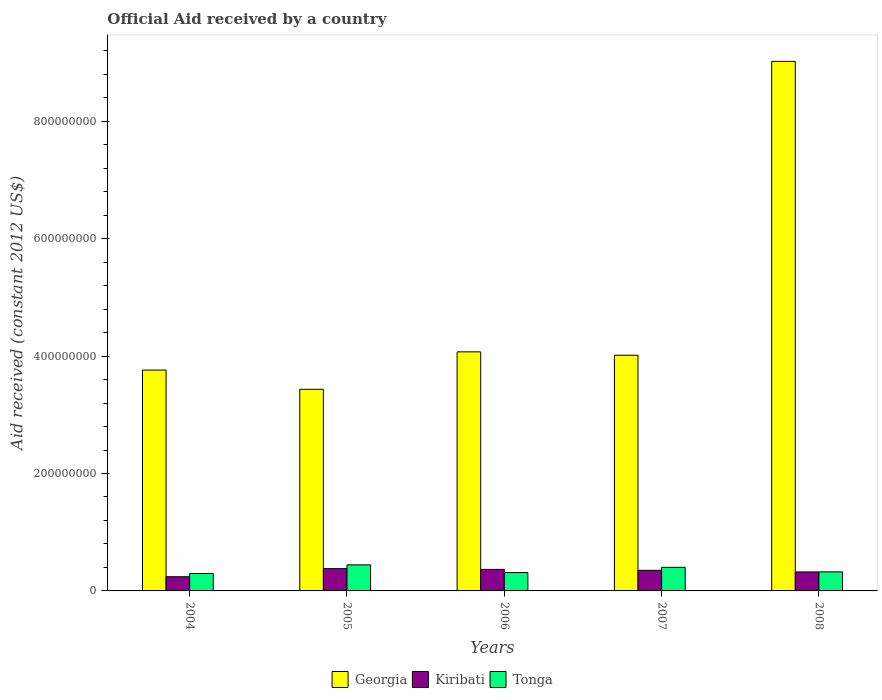How many different coloured bars are there?
Your answer should be very brief. 3. Are the number of bars per tick equal to the number of legend labels?
Provide a short and direct response. Yes. What is the label of the 5th group of bars from the left?
Provide a succinct answer. 2008. What is the net official aid received in Tonga in 2007?
Your response must be concise. 4.02e+07. Across all years, what is the maximum net official aid received in Kiribati?
Your answer should be very brief. 3.80e+07. Across all years, what is the minimum net official aid received in Kiribati?
Your response must be concise. 2.42e+07. In which year was the net official aid received in Georgia maximum?
Offer a very short reply. 2008. What is the total net official aid received in Tonga in the graph?
Your answer should be very brief. 1.78e+08. What is the difference between the net official aid received in Georgia in 2004 and that in 2007?
Your answer should be very brief. -2.53e+07. What is the difference between the net official aid received in Tonga in 2006 and the net official aid received in Georgia in 2004?
Provide a succinct answer. -3.45e+08. What is the average net official aid received in Georgia per year?
Your response must be concise. 4.86e+08. In the year 2006, what is the difference between the net official aid received in Georgia and net official aid received in Kiribati?
Your answer should be compact. 3.71e+08. In how many years, is the net official aid received in Georgia greater than 720000000 US$?
Keep it short and to the point. 1. What is the ratio of the net official aid received in Georgia in 2004 to that in 2007?
Make the answer very short. 0.94. What is the difference between the highest and the second highest net official aid received in Tonga?
Ensure brevity in your answer.  4.17e+06. What is the difference between the highest and the lowest net official aid received in Kiribati?
Your response must be concise. 1.38e+07. In how many years, is the net official aid received in Georgia greater than the average net official aid received in Georgia taken over all years?
Offer a very short reply. 1. Is the sum of the net official aid received in Kiribati in 2005 and 2008 greater than the maximum net official aid received in Tonga across all years?
Keep it short and to the point. Yes. What does the 3rd bar from the left in 2004 represents?
Make the answer very short. Tonga. What does the 1st bar from the right in 2008 represents?
Your answer should be very brief. Tonga. How many bars are there?
Your response must be concise. 15. Are all the bars in the graph horizontal?
Your answer should be very brief. No. How many years are there in the graph?
Make the answer very short. 5. What is the difference between two consecutive major ticks on the Y-axis?
Give a very brief answer. 2.00e+08. Are the values on the major ticks of Y-axis written in scientific E-notation?
Your answer should be very brief. No. Does the graph contain any zero values?
Make the answer very short. No. Does the graph contain grids?
Provide a succinct answer. No. Where does the legend appear in the graph?
Offer a terse response. Bottom center. How many legend labels are there?
Your response must be concise. 3. How are the legend labels stacked?
Provide a succinct answer. Horizontal. What is the title of the graph?
Make the answer very short. Official Aid received by a country. Does "Burkina Faso" appear as one of the legend labels in the graph?
Your answer should be compact. No. What is the label or title of the X-axis?
Ensure brevity in your answer.  Years. What is the label or title of the Y-axis?
Keep it short and to the point. Aid received (constant 2012 US$). What is the Aid received (constant 2012 US$) of Georgia in 2004?
Provide a succinct answer. 3.76e+08. What is the Aid received (constant 2012 US$) of Kiribati in 2004?
Provide a succinct answer. 2.42e+07. What is the Aid received (constant 2012 US$) of Tonga in 2004?
Your response must be concise. 2.96e+07. What is the Aid received (constant 2012 US$) of Georgia in 2005?
Give a very brief answer. 3.43e+08. What is the Aid received (constant 2012 US$) in Kiribati in 2005?
Your response must be concise. 3.80e+07. What is the Aid received (constant 2012 US$) in Tonga in 2005?
Offer a very short reply. 4.44e+07. What is the Aid received (constant 2012 US$) of Georgia in 2006?
Give a very brief answer. 4.07e+08. What is the Aid received (constant 2012 US$) in Kiribati in 2006?
Offer a very short reply. 3.67e+07. What is the Aid received (constant 2012 US$) in Tonga in 2006?
Ensure brevity in your answer.  3.12e+07. What is the Aid received (constant 2012 US$) in Georgia in 2007?
Your answer should be compact. 4.02e+08. What is the Aid received (constant 2012 US$) in Kiribati in 2007?
Make the answer very short. 3.51e+07. What is the Aid received (constant 2012 US$) in Tonga in 2007?
Your answer should be very brief. 4.02e+07. What is the Aid received (constant 2012 US$) of Georgia in 2008?
Give a very brief answer. 9.02e+08. What is the Aid received (constant 2012 US$) of Kiribati in 2008?
Your response must be concise. 3.23e+07. What is the Aid received (constant 2012 US$) of Tonga in 2008?
Your answer should be very brief. 3.24e+07. Across all years, what is the maximum Aid received (constant 2012 US$) of Georgia?
Your answer should be compact. 9.02e+08. Across all years, what is the maximum Aid received (constant 2012 US$) in Kiribati?
Your answer should be very brief. 3.80e+07. Across all years, what is the maximum Aid received (constant 2012 US$) in Tonga?
Your answer should be very brief. 4.44e+07. Across all years, what is the minimum Aid received (constant 2012 US$) in Georgia?
Keep it short and to the point. 3.43e+08. Across all years, what is the minimum Aid received (constant 2012 US$) in Kiribati?
Your response must be concise. 2.42e+07. Across all years, what is the minimum Aid received (constant 2012 US$) in Tonga?
Offer a very short reply. 2.96e+07. What is the total Aid received (constant 2012 US$) in Georgia in the graph?
Offer a terse response. 2.43e+09. What is the total Aid received (constant 2012 US$) in Kiribati in the graph?
Offer a terse response. 1.66e+08. What is the total Aid received (constant 2012 US$) of Tonga in the graph?
Offer a very short reply. 1.78e+08. What is the difference between the Aid received (constant 2012 US$) of Georgia in 2004 and that in 2005?
Provide a short and direct response. 3.28e+07. What is the difference between the Aid received (constant 2012 US$) of Kiribati in 2004 and that in 2005?
Offer a terse response. -1.38e+07. What is the difference between the Aid received (constant 2012 US$) of Tonga in 2004 and that in 2005?
Give a very brief answer. -1.47e+07. What is the difference between the Aid received (constant 2012 US$) in Georgia in 2004 and that in 2006?
Ensure brevity in your answer.  -3.10e+07. What is the difference between the Aid received (constant 2012 US$) in Kiribati in 2004 and that in 2006?
Make the answer very short. -1.25e+07. What is the difference between the Aid received (constant 2012 US$) in Tonga in 2004 and that in 2006?
Offer a terse response. -1.61e+06. What is the difference between the Aid received (constant 2012 US$) of Georgia in 2004 and that in 2007?
Give a very brief answer. -2.53e+07. What is the difference between the Aid received (constant 2012 US$) in Kiribati in 2004 and that in 2007?
Keep it short and to the point. -1.09e+07. What is the difference between the Aid received (constant 2012 US$) in Tonga in 2004 and that in 2007?
Your answer should be very brief. -1.06e+07. What is the difference between the Aid received (constant 2012 US$) of Georgia in 2004 and that in 2008?
Your response must be concise. -5.26e+08. What is the difference between the Aid received (constant 2012 US$) of Kiribati in 2004 and that in 2008?
Offer a terse response. -8.15e+06. What is the difference between the Aid received (constant 2012 US$) in Tonga in 2004 and that in 2008?
Provide a succinct answer. -2.80e+06. What is the difference between the Aid received (constant 2012 US$) of Georgia in 2005 and that in 2006?
Offer a very short reply. -6.38e+07. What is the difference between the Aid received (constant 2012 US$) in Kiribati in 2005 and that in 2006?
Provide a succinct answer. 1.26e+06. What is the difference between the Aid received (constant 2012 US$) in Tonga in 2005 and that in 2006?
Make the answer very short. 1.31e+07. What is the difference between the Aid received (constant 2012 US$) in Georgia in 2005 and that in 2007?
Give a very brief answer. -5.81e+07. What is the difference between the Aid received (constant 2012 US$) in Kiribati in 2005 and that in 2007?
Your answer should be very brief. 2.86e+06. What is the difference between the Aid received (constant 2012 US$) of Tonga in 2005 and that in 2007?
Keep it short and to the point. 4.17e+06. What is the difference between the Aid received (constant 2012 US$) of Georgia in 2005 and that in 2008?
Keep it short and to the point. -5.59e+08. What is the difference between the Aid received (constant 2012 US$) of Kiribati in 2005 and that in 2008?
Your answer should be very brief. 5.62e+06. What is the difference between the Aid received (constant 2012 US$) in Tonga in 2005 and that in 2008?
Your answer should be compact. 1.19e+07. What is the difference between the Aid received (constant 2012 US$) of Georgia in 2006 and that in 2007?
Provide a succinct answer. 5.75e+06. What is the difference between the Aid received (constant 2012 US$) in Kiribati in 2006 and that in 2007?
Your answer should be very brief. 1.60e+06. What is the difference between the Aid received (constant 2012 US$) of Tonga in 2006 and that in 2007?
Your answer should be compact. -8.95e+06. What is the difference between the Aid received (constant 2012 US$) of Georgia in 2006 and that in 2008?
Your answer should be compact. -4.95e+08. What is the difference between the Aid received (constant 2012 US$) of Kiribati in 2006 and that in 2008?
Make the answer very short. 4.36e+06. What is the difference between the Aid received (constant 2012 US$) in Tonga in 2006 and that in 2008?
Your answer should be compact. -1.19e+06. What is the difference between the Aid received (constant 2012 US$) of Georgia in 2007 and that in 2008?
Your answer should be compact. -5.01e+08. What is the difference between the Aid received (constant 2012 US$) in Kiribati in 2007 and that in 2008?
Provide a succinct answer. 2.76e+06. What is the difference between the Aid received (constant 2012 US$) in Tonga in 2007 and that in 2008?
Make the answer very short. 7.76e+06. What is the difference between the Aid received (constant 2012 US$) in Georgia in 2004 and the Aid received (constant 2012 US$) in Kiribati in 2005?
Keep it short and to the point. 3.38e+08. What is the difference between the Aid received (constant 2012 US$) of Georgia in 2004 and the Aid received (constant 2012 US$) of Tonga in 2005?
Your answer should be compact. 3.32e+08. What is the difference between the Aid received (constant 2012 US$) in Kiribati in 2004 and the Aid received (constant 2012 US$) in Tonga in 2005?
Give a very brief answer. -2.02e+07. What is the difference between the Aid received (constant 2012 US$) in Georgia in 2004 and the Aid received (constant 2012 US$) in Kiribati in 2006?
Make the answer very short. 3.40e+08. What is the difference between the Aid received (constant 2012 US$) in Georgia in 2004 and the Aid received (constant 2012 US$) in Tonga in 2006?
Your answer should be compact. 3.45e+08. What is the difference between the Aid received (constant 2012 US$) in Kiribati in 2004 and the Aid received (constant 2012 US$) in Tonga in 2006?
Provide a short and direct response. -7.06e+06. What is the difference between the Aid received (constant 2012 US$) of Georgia in 2004 and the Aid received (constant 2012 US$) of Kiribati in 2007?
Your answer should be very brief. 3.41e+08. What is the difference between the Aid received (constant 2012 US$) in Georgia in 2004 and the Aid received (constant 2012 US$) in Tonga in 2007?
Offer a terse response. 3.36e+08. What is the difference between the Aid received (constant 2012 US$) of Kiribati in 2004 and the Aid received (constant 2012 US$) of Tonga in 2007?
Your answer should be very brief. -1.60e+07. What is the difference between the Aid received (constant 2012 US$) of Georgia in 2004 and the Aid received (constant 2012 US$) of Kiribati in 2008?
Your answer should be compact. 3.44e+08. What is the difference between the Aid received (constant 2012 US$) in Georgia in 2004 and the Aid received (constant 2012 US$) in Tonga in 2008?
Your answer should be very brief. 3.44e+08. What is the difference between the Aid received (constant 2012 US$) of Kiribati in 2004 and the Aid received (constant 2012 US$) of Tonga in 2008?
Offer a very short reply. -8.25e+06. What is the difference between the Aid received (constant 2012 US$) of Georgia in 2005 and the Aid received (constant 2012 US$) of Kiribati in 2006?
Offer a very short reply. 3.07e+08. What is the difference between the Aid received (constant 2012 US$) in Georgia in 2005 and the Aid received (constant 2012 US$) in Tonga in 2006?
Your response must be concise. 3.12e+08. What is the difference between the Aid received (constant 2012 US$) of Kiribati in 2005 and the Aid received (constant 2012 US$) of Tonga in 2006?
Keep it short and to the point. 6.71e+06. What is the difference between the Aid received (constant 2012 US$) in Georgia in 2005 and the Aid received (constant 2012 US$) in Kiribati in 2007?
Provide a short and direct response. 3.08e+08. What is the difference between the Aid received (constant 2012 US$) of Georgia in 2005 and the Aid received (constant 2012 US$) of Tonga in 2007?
Make the answer very short. 3.03e+08. What is the difference between the Aid received (constant 2012 US$) of Kiribati in 2005 and the Aid received (constant 2012 US$) of Tonga in 2007?
Give a very brief answer. -2.24e+06. What is the difference between the Aid received (constant 2012 US$) in Georgia in 2005 and the Aid received (constant 2012 US$) in Kiribati in 2008?
Keep it short and to the point. 3.11e+08. What is the difference between the Aid received (constant 2012 US$) in Georgia in 2005 and the Aid received (constant 2012 US$) in Tonga in 2008?
Provide a succinct answer. 3.11e+08. What is the difference between the Aid received (constant 2012 US$) of Kiribati in 2005 and the Aid received (constant 2012 US$) of Tonga in 2008?
Ensure brevity in your answer.  5.52e+06. What is the difference between the Aid received (constant 2012 US$) of Georgia in 2006 and the Aid received (constant 2012 US$) of Kiribati in 2007?
Provide a short and direct response. 3.72e+08. What is the difference between the Aid received (constant 2012 US$) of Georgia in 2006 and the Aid received (constant 2012 US$) of Tonga in 2007?
Your answer should be very brief. 3.67e+08. What is the difference between the Aid received (constant 2012 US$) in Kiribati in 2006 and the Aid received (constant 2012 US$) in Tonga in 2007?
Your answer should be compact. -3.50e+06. What is the difference between the Aid received (constant 2012 US$) of Georgia in 2006 and the Aid received (constant 2012 US$) of Kiribati in 2008?
Your response must be concise. 3.75e+08. What is the difference between the Aid received (constant 2012 US$) of Georgia in 2006 and the Aid received (constant 2012 US$) of Tonga in 2008?
Your answer should be compact. 3.75e+08. What is the difference between the Aid received (constant 2012 US$) of Kiribati in 2006 and the Aid received (constant 2012 US$) of Tonga in 2008?
Provide a short and direct response. 4.26e+06. What is the difference between the Aid received (constant 2012 US$) in Georgia in 2007 and the Aid received (constant 2012 US$) in Kiribati in 2008?
Your answer should be compact. 3.69e+08. What is the difference between the Aid received (constant 2012 US$) in Georgia in 2007 and the Aid received (constant 2012 US$) in Tonga in 2008?
Provide a succinct answer. 3.69e+08. What is the difference between the Aid received (constant 2012 US$) in Kiribati in 2007 and the Aid received (constant 2012 US$) in Tonga in 2008?
Your response must be concise. 2.66e+06. What is the average Aid received (constant 2012 US$) in Georgia per year?
Offer a terse response. 4.86e+08. What is the average Aid received (constant 2012 US$) in Kiribati per year?
Your response must be concise. 3.33e+07. What is the average Aid received (constant 2012 US$) of Tonga per year?
Keep it short and to the point. 3.56e+07. In the year 2004, what is the difference between the Aid received (constant 2012 US$) in Georgia and Aid received (constant 2012 US$) in Kiribati?
Give a very brief answer. 3.52e+08. In the year 2004, what is the difference between the Aid received (constant 2012 US$) of Georgia and Aid received (constant 2012 US$) of Tonga?
Offer a very short reply. 3.47e+08. In the year 2004, what is the difference between the Aid received (constant 2012 US$) in Kiribati and Aid received (constant 2012 US$) in Tonga?
Your answer should be very brief. -5.45e+06. In the year 2005, what is the difference between the Aid received (constant 2012 US$) in Georgia and Aid received (constant 2012 US$) in Kiribati?
Your response must be concise. 3.05e+08. In the year 2005, what is the difference between the Aid received (constant 2012 US$) in Georgia and Aid received (constant 2012 US$) in Tonga?
Offer a very short reply. 2.99e+08. In the year 2005, what is the difference between the Aid received (constant 2012 US$) of Kiribati and Aid received (constant 2012 US$) of Tonga?
Give a very brief answer. -6.41e+06. In the year 2006, what is the difference between the Aid received (constant 2012 US$) of Georgia and Aid received (constant 2012 US$) of Kiribati?
Your answer should be very brief. 3.71e+08. In the year 2006, what is the difference between the Aid received (constant 2012 US$) of Georgia and Aid received (constant 2012 US$) of Tonga?
Make the answer very short. 3.76e+08. In the year 2006, what is the difference between the Aid received (constant 2012 US$) in Kiribati and Aid received (constant 2012 US$) in Tonga?
Offer a terse response. 5.45e+06. In the year 2007, what is the difference between the Aid received (constant 2012 US$) in Georgia and Aid received (constant 2012 US$) in Kiribati?
Make the answer very short. 3.66e+08. In the year 2007, what is the difference between the Aid received (constant 2012 US$) in Georgia and Aid received (constant 2012 US$) in Tonga?
Make the answer very short. 3.61e+08. In the year 2007, what is the difference between the Aid received (constant 2012 US$) in Kiribati and Aid received (constant 2012 US$) in Tonga?
Provide a succinct answer. -5.10e+06. In the year 2008, what is the difference between the Aid received (constant 2012 US$) of Georgia and Aid received (constant 2012 US$) of Kiribati?
Offer a very short reply. 8.70e+08. In the year 2008, what is the difference between the Aid received (constant 2012 US$) of Georgia and Aid received (constant 2012 US$) of Tonga?
Give a very brief answer. 8.70e+08. What is the ratio of the Aid received (constant 2012 US$) in Georgia in 2004 to that in 2005?
Your response must be concise. 1.1. What is the ratio of the Aid received (constant 2012 US$) of Kiribati in 2004 to that in 2005?
Your answer should be compact. 0.64. What is the ratio of the Aid received (constant 2012 US$) of Tonga in 2004 to that in 2005?
Provide a short and direct response. 0.67. What is the ratio of the Aid received (constant 2012 US$) of Georgia in 2004 to that in 2006?
Offer a terse response. 0.92. What is the ratio of the Aid received (constant 2012 US$) of Kiribati in 2004 to that in 2006?
Offer a very short reply. 0.66. What is the ratio of the Aid received (constant 2012 US$) in Tonga in 2004 to that in 2006?
Offer a very short reply. 0.95. What is the ratio of the Aid received (constant 2012 US$) of Georgia in 2004 to that in 2007?
Make the answer very short. 0.94. What is the ratio of the Aid received (constant 2012 US$) in Kiribati in 2004 to that in 2007?
Provide a succinct answer. 0.69. What is the ratio of the Aid received (constant 2012 US$) of Tonga in 2004 to that in 2007?
Keep it short and to the point. 0.74. What is the ratio of the Aid received (constant 2012 US$) in Georgia in 2004 to that in 2008?
Make the answer very short. 0.42. What is the ratio of the Aid received (constant 2012 US$) in Kiribati in 2004 to that in 2008?
Give a very brief answer. 0.75. What is the ratio of the Aid received (constant 2012 US$) of Tonga in 2004 to that in 2008?
Ensure brevity in your answer.  0.91. What is the ratio of the Aid received (constant 2012 US$) in Georgia in 2005 to that in 2006?
Keep it short and to the point. 0.84. What is the ratio of the Aid received (constant 2012 US$) in Kiribati in 2005 to that in 2006?
Keep it short and to the point. 1.03. What is the ratio of the Aid received (constant 2012 US$) in Tonga in 2005 to that in 2006?
Provide a short and direct response. 1.42. What is the ratio of the Aid received (constant 2012 US$) in Georgia in 2005 to that in 2007?
Your response must be concise. 0.86. What is the ratio of the Aid received (constant 2012 US$) in Kiribati in 2005 to that in 2007?
Provide a succinct answer. 1.08. What is the ratio of the Aid received (constant 2012 US$) in Tonga in 2005 to that in 2007?
Offer a very short reply. 1.1. What is the ratio of the Aid received (constant 2012 US$) in Georgia in 2005 to that in 2008?
Provide a short and direct response. 0.38. What is the ratio of the Aid received (constant 2012 US$) of Kiribati in 2005 to that in 2008?
Make the answer very short. 1.17. What is the ratio of the Aid received (constant 2012 US$) of Tonga in 2005 to that in 2008?
Your answer should be very brief. 1.37. What is the ratio of the Aid received (constant 2012 US$) in Georgia in 2006 to that in 2007?
Provide a short and direct response. 1.01. What is the ratio of the Aid received (constant 2012 US$) in Kiribati in 2006 to that in 2007?
Your answer should be compact. 1.05. What is the ratio of the Aid received (constant 2012 US$) in Tonga in 2006 to that in 2007?
Provide a short and direct response. 0.78. What is the ratio of the Aid received (constant 2012 US$) of Georgia in 2006 to that in 2008?
Your response must be concise. 0.45. What is the ratio of the Aid received (constant 2012 US$) of Kiribati in 2006 to that in 2008?
Give a very brief answer. 1.13. What is the ratio of the Aid received (constant 2012 US$) in Tonga in 2006 to that in 2008?
Your answer should be compact. 0.96. What is the ratio of the Aid received (constant 2012 US$) of Georgia in 2007 to that in 2008?
Offer a terse response. 0.45. What is the ratio of the Aid received (constant 2012 US$) in Kiribati in 2007 to that in 2008?
Ensure brevity in your answer.  1.09. What is the ratio of the Aid received (constant 2012 US$) of Tonga in 2007 to that in 2008?
Provide a succinct answer. 1.24. What is the difference between the highest and the second highest Aid received (constant 2012 US$) of Georgia?
Keep it short and to the point. 4.95e+08. What is the difference between the highest and the second highest Aid received (constant 2012 US$) of Kiribati?
Ensure brevity in your answer.  1.26e+06. What is the difference between the highest and the second highest Aid received (constant 2012 US$) of Tonga?
Your answer should be compact. 4.17e+06. What is the difference between the highest and the lowest Aid received (constant 2012 US$) of Georgia?
Offer a very short reply. 5.59e+08. What is the difference between the highest and the lowest Aid received (constant 2012 US$) in Kiribati?
Offer a terse response. 1.38e+07. What is the difference between the highest and the lowest Aid received (constant 2012 US$) of Tonga?
Provide a short and direct response. 1.47e+07. 